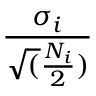<formula> <loc_0><loc_0><loc_500><loc_500>\frac { \sigma _ { i } } { \sqrt { ( } \frac { N _ { i } } { 2 } ) }</formula> 